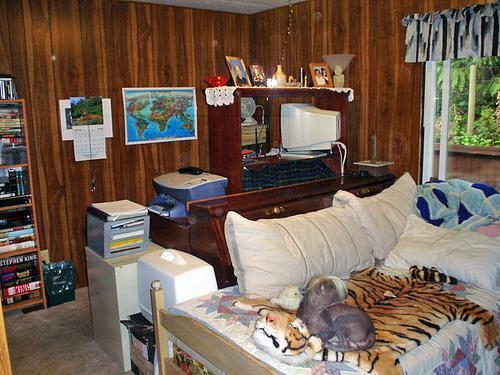How many people are stepping off of a train?
Give a very brief answer. 0. 